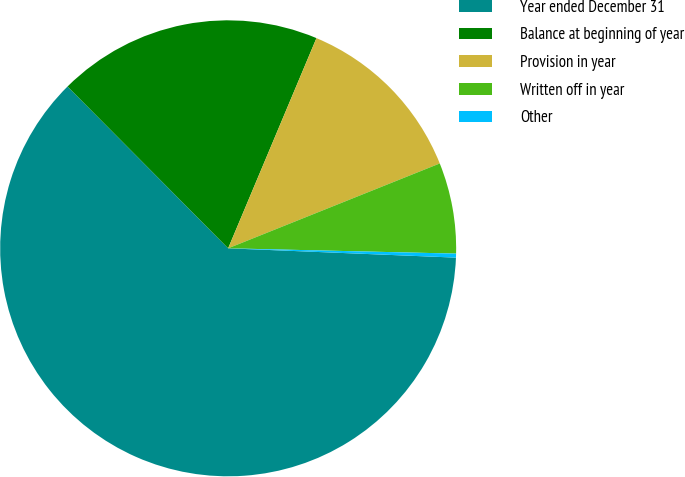Convert chart to OTSL. <chart><loc_0><loc_0><loc_500><loc_500><pie_chart><fcel>Year ended December 31<fcel>Balance at beginning of year<fcel>Provision in year<fcel>Written off in year<fcel>Other<nl><fcel>61.91%<fcel>18.77%<fcel>12.6%<fcel>6.44%<fcel>0.28%<nl></chart> 